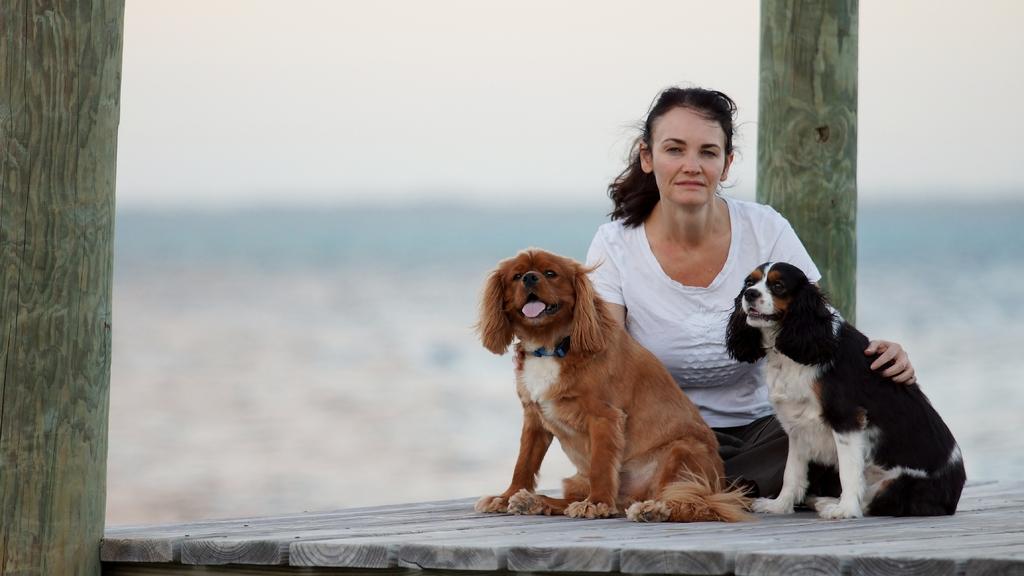How would you summarize this image in a sentence or two? This woman wore white t-shirt. In-front of this woman there are dogs. 